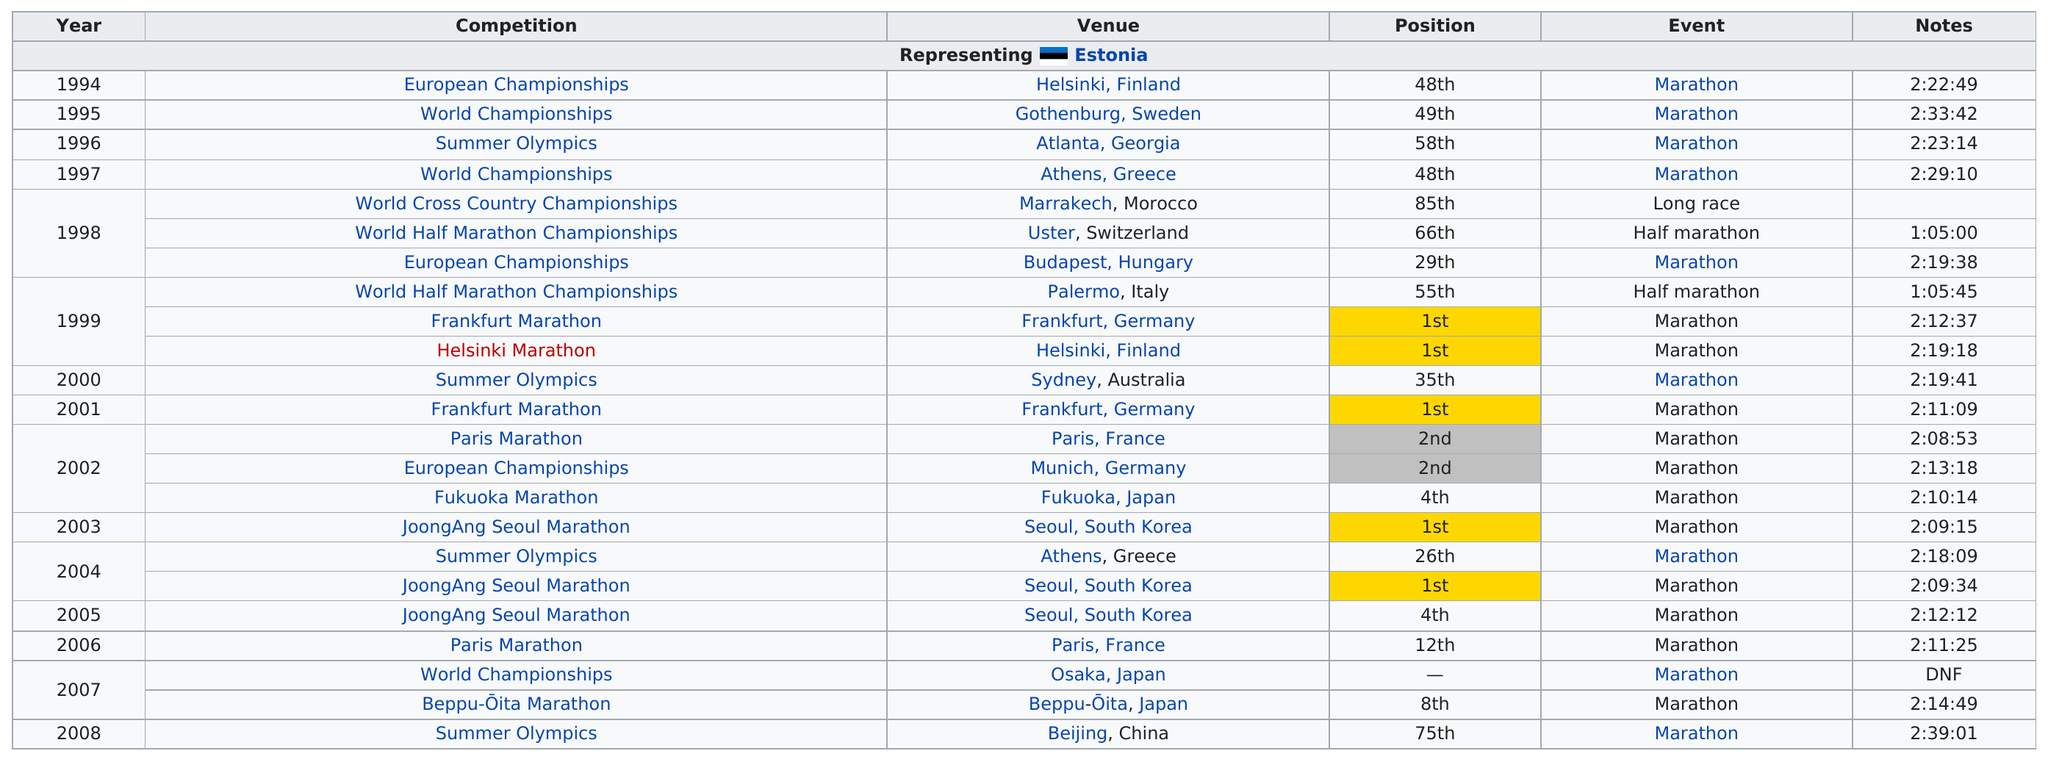Draw attention to some important aspects in this diagram. The result was a first-place finish in 5 marathons. Pavel Loskutov ran a total of three marathons in a single year. Pavel Loskutov has come in first in a marathon a total of five times throughout his life. He came in first place a total of 5 times. Pavel Loskutov ran in the Joongang Seoul Marathon consecutively for three years. 